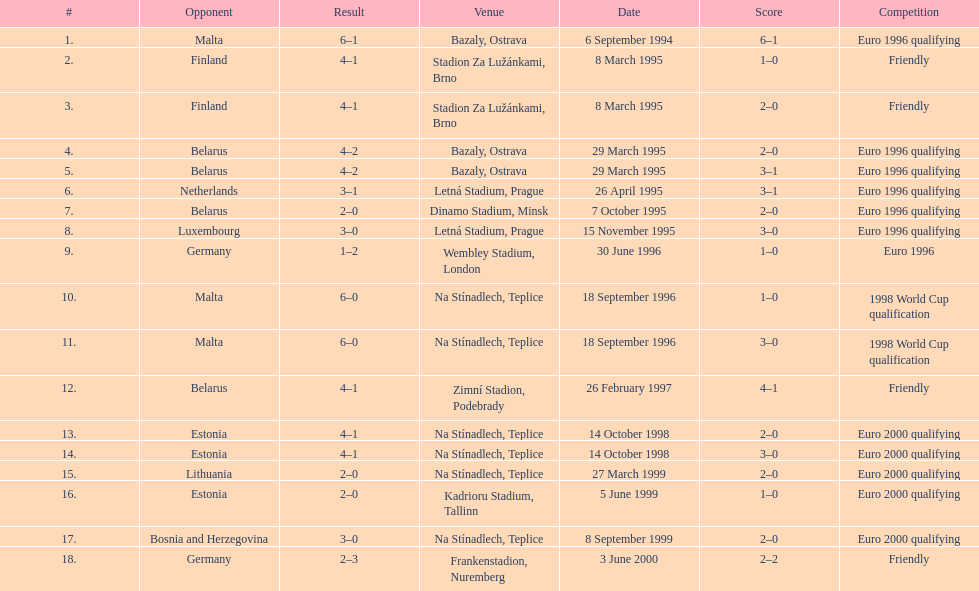What opponent is listed last on the table? Germany. I'm looking to parse the entire table for insights. Could you assist me with that? {'header': ['#', 'Opponent', 'Result', 'Venue', 'Date', 'Score', 'Competition'], 'rows': [['1.', 'Malta', '6–1', 'Bazaly, Ostrava', '6 September 1994', '6–1', 'Euro 1996 qualifying'], ['2.', 'Finland', '4–1', 'Stadion Za Lužánkami, Brno', '8 March 1995', '1–0', 'Friendly'], ['3.', 'Finland', '4–1', 'Stadion Za Lužánkami, Brno', '8 March 1995', '2–0', 'Friendly'], ['4.', 'Belarus', '4–2', 'Bazaly, Ostrava', '29 March 1995', '2–0', 'Euro 1996 qualifying'], ['5.', 'Belarus', '4–2', 'Bazaly, Ostrava', '29 March 1995', '3–1', 'Euro 1996 qualifying'], ['6.', 'Netherlands', '3–1', 'Letná Stadium, Prague', '26 April 1995', '3–1', 'Euro 1996 qualifying'], ['7.', 'Belarus', '2–0', 'Dinamo Stadium, Minsk', '7 October 1995', '2–0', 'Euro 1996 qualifying'], ['8.', 'Luxembourg', '3–0', 'Letná Stadium, Prague', '15 November 1995', '3–0', 'Euro 1996 qualifying'], ['9.', 'Germany', '1–2', 'Wembley Stadium, London', '30 June 1996', '1–0', 'Euro 1996'], ['10.', 'Malta', '6–0', 'Na Stínadlech, Teplice', '18 September 1996', '1–0', '1998 World Cup qualification'], ['11.', 'Malta', '6–0', 'Na Stínadlech, Teplice', '18 September 1996', '3–0', '1998 World Cup qualification'], ['12.', 'Belarus', '4–1', 'Zimní Stadion, Podebrady', '26 February 1997', '4–1', 'Friendly'], ['13.', 'Estonia', '4–1', 'Na Stínadlech, Teplice', '14 October 1998', '2–0', 'Euro 2000 qualifying'], ['14.', 'Estonia', '4–1', 'Na Stínadlech, Teplice', '14 October 1998', '3–0', 'Euro 2000 qualifying'], ['15.', 'Lithuania', '2–0', 'Na Stínadlech, Teplice', '27 March 1999', '2–0', 'Euro 2000 qualifying'], ['16.', 'Estonia', '2–0', 'Kadrioru Stadium, Tallinn', '5 June 1999', '1–0', 'Euro 2000 qualifying'], ['17.', 'Bosnia and Herzegovina', '3–0', 'Na Stínadlech, Teplice', '8 September 1999', '2–0', 'Euro 2000 qualifying'], ['18.', 'Germany', '2–3', 'Frankenstadion, Nuremberg', '3 June 2000', '2–2', 'Friendly']]} 